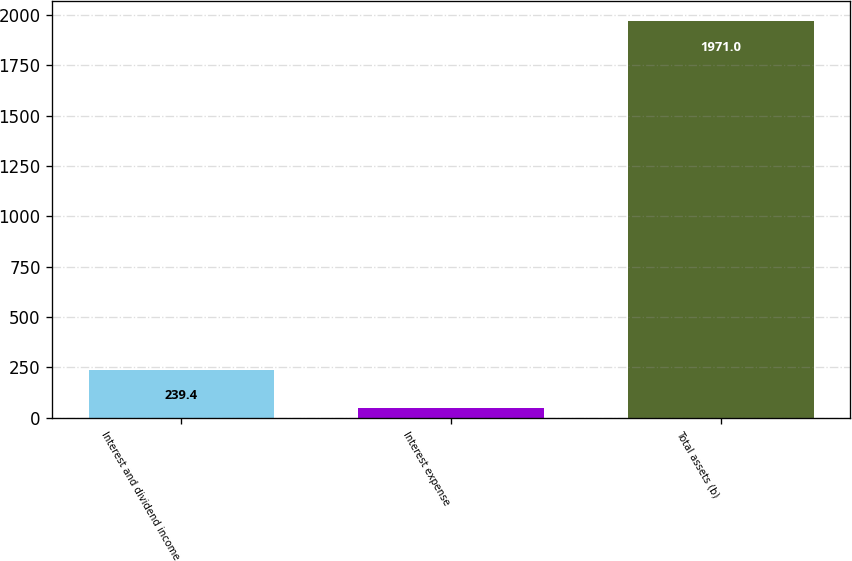Convert chart to OTSL. <chart><loc_0><loc_0><loc_500><loc_500><bar_chart><fcel>Interest and dividend income<fcel>Interest expense<fcel>Total assets (b)<nl><fcel>239.4<fcel>47<fcel>1971<nl></chart> 